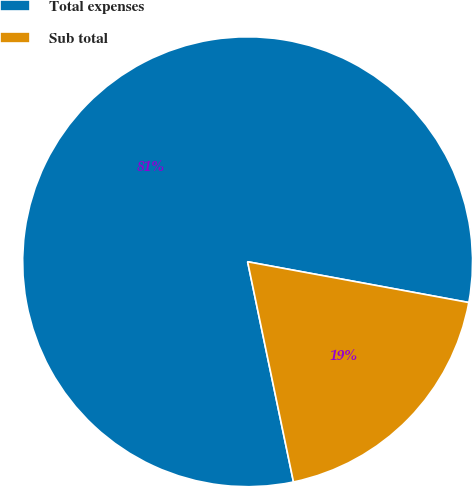Convert chart. <chart><loc_0><loc_0><loc_500><loc_500><pie_chart><fcel>Total expenses<fcel>Sub total<nl><fcel>81.17%<fcel>18.83%<nl></chart> 